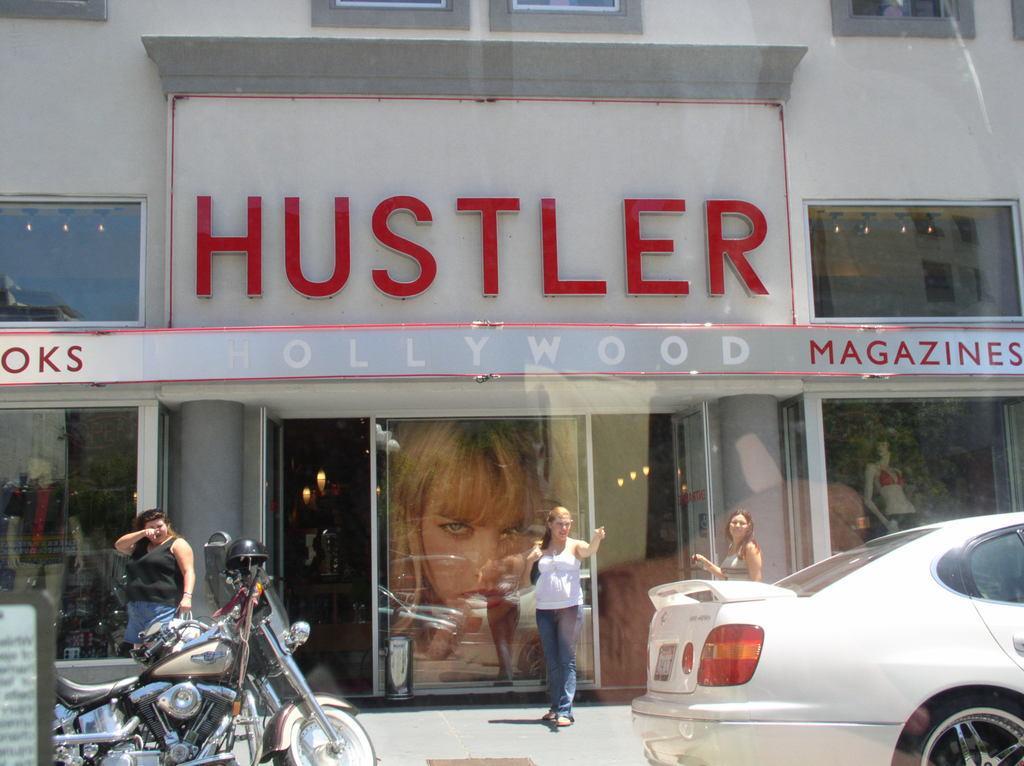Could you give a brief overview of what you see in this image? In the center of the image we can see building, windows, boards, door, wall, glass. Through glass we can see lights, mannequins. At the bottom of the image we can see three persons are standing and also we can see motorcycle, car, floor and board. 